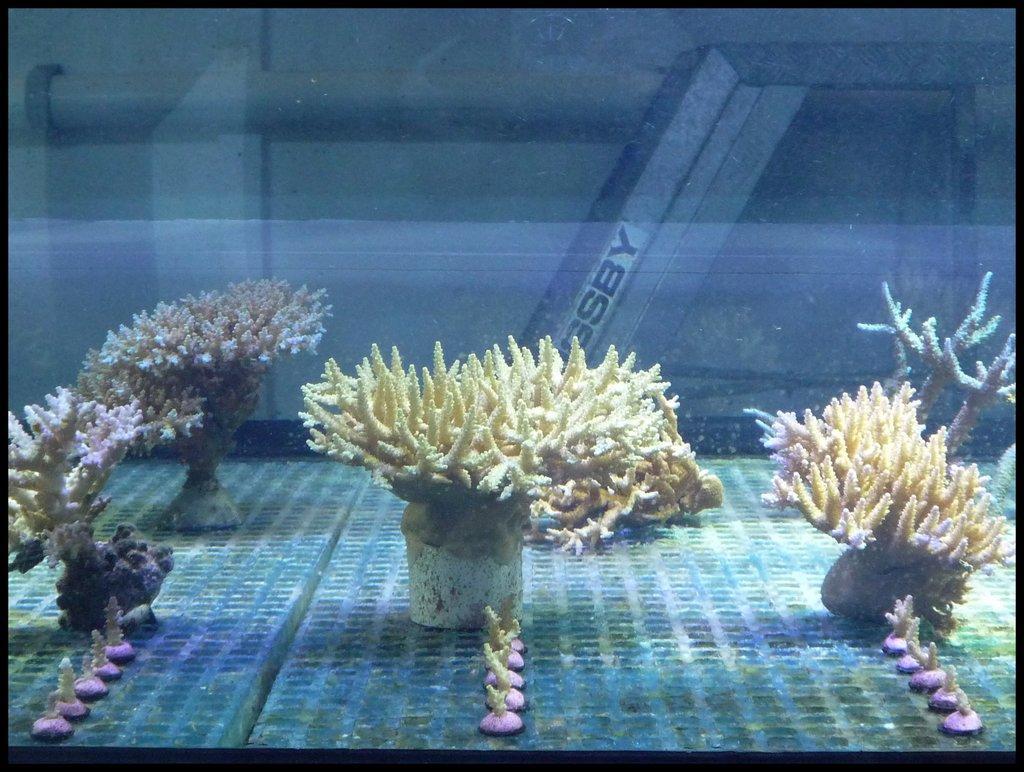Describe this image in one or two sentences. In this image we can see corals in the water. In the back there is a pillar with text. 